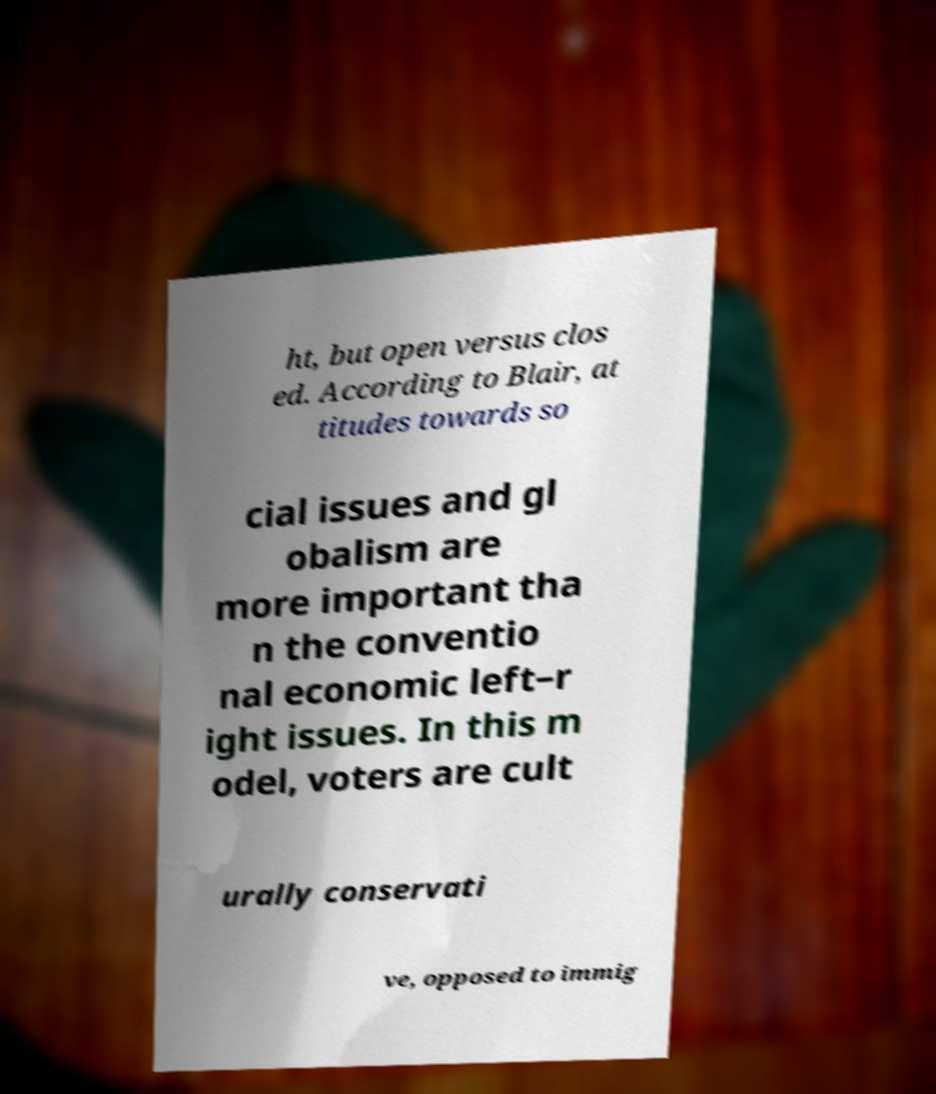Could you extract and type out the text from this image? ht, but open versus clos ed. According to Blair, at titudes towards so cial issues and gl obalism are more important tha n the conventio nal economic left–r ight issues. In this m odel, voters are cult urally conservati ve, opposed to immig 